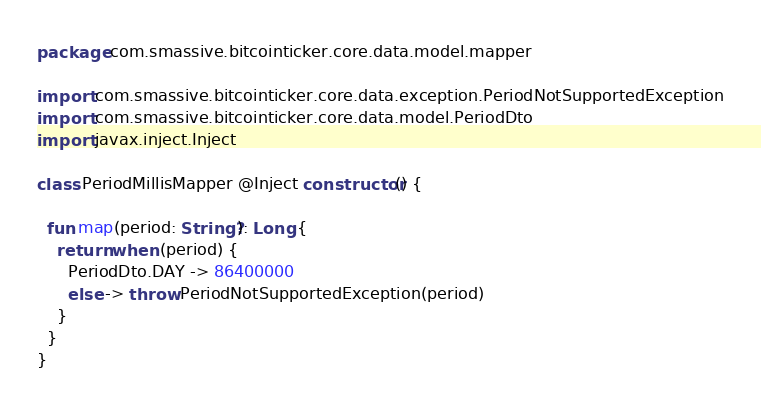Convert code to text. <code><loc_0><loc_0><loc_500><loc_500><_Kotlin_>package com.smassive.bitcointicker.core.data.model.mapper

import com.smassive.bitcointicker.core.data.exception.PeriodNotSupportedException
import com.smassive.bitcointicker.core.data.model.PeriodDto
import javax.inject.Inject

class PeriodMillisMapper @Inject constructor() {

  fun map(period: String?): Long {
    return when (period) {
      PeriodDto.DAY -> 86400000
      else -> throw PeriodNotSupportedException(period)
    }
  }
}</code> 